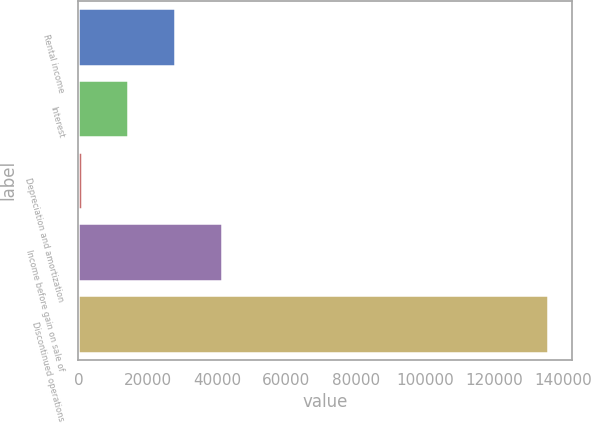Convert chart. <chart><loc_0><loc_0><loc_500><loc_500><bar_chart><fcel>Rental income<fcel>Interest<fcel>Depreciation and amortization<fcel>Income before gain on sale of<fcel>Discontinued operations<nl><fcel>27911<fcel>14447<fcel>983<fcel>41375<fcel>135623<nl></chart> 